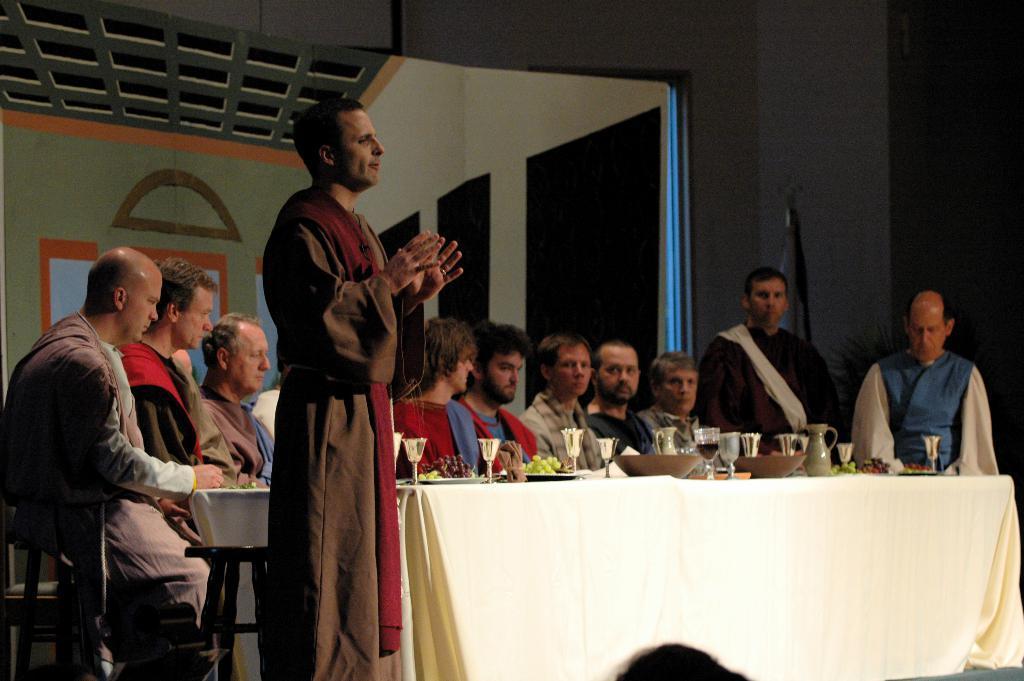Describe this image in one or two sentences. a person is standing wearing a brown dress. behind him people are sitting on the chairs. at the right ,2 persons are standing. in front of them there is a table on which there are glass, fruit, bowls. 